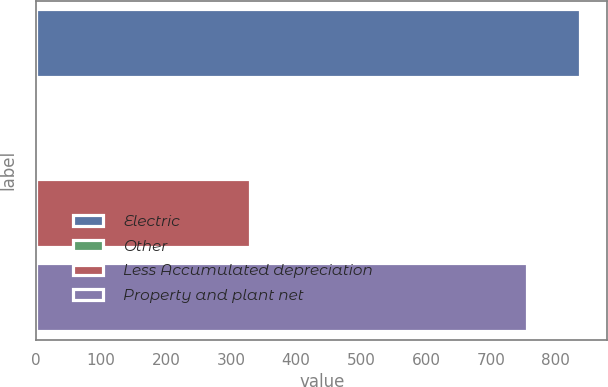Convert chart to OTSL. <chart><loc_0><loc_0><loc_500><loc_500><bar_chart><fcel>Electric<fcel>Other<fcel>Less Accumulated depreciation<fcel>Property and plant net<nl><fcel>837.6<fcel>1<fcel>329<fcel>755<nl></chart> 